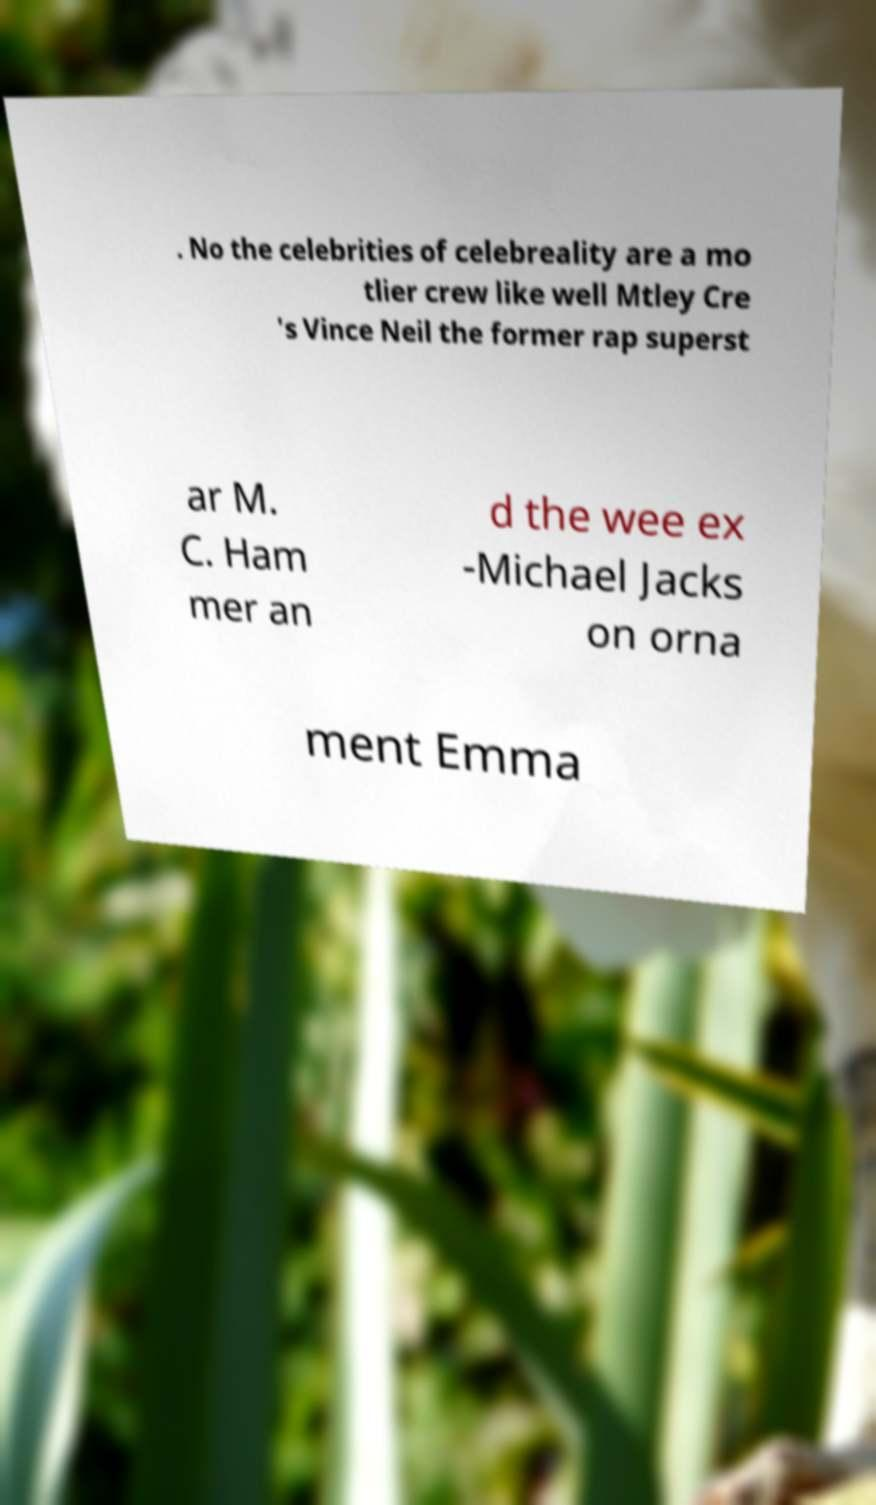I need the written content from this picture converted into text. Can you do that? . No the celebrities of celebreality are a mo tlier crew like well Mtley Cre 's Vince Neil the former rap superst ar M. C. Ham mer an d the wee ex -Michael Jacks on orna ment Emma 